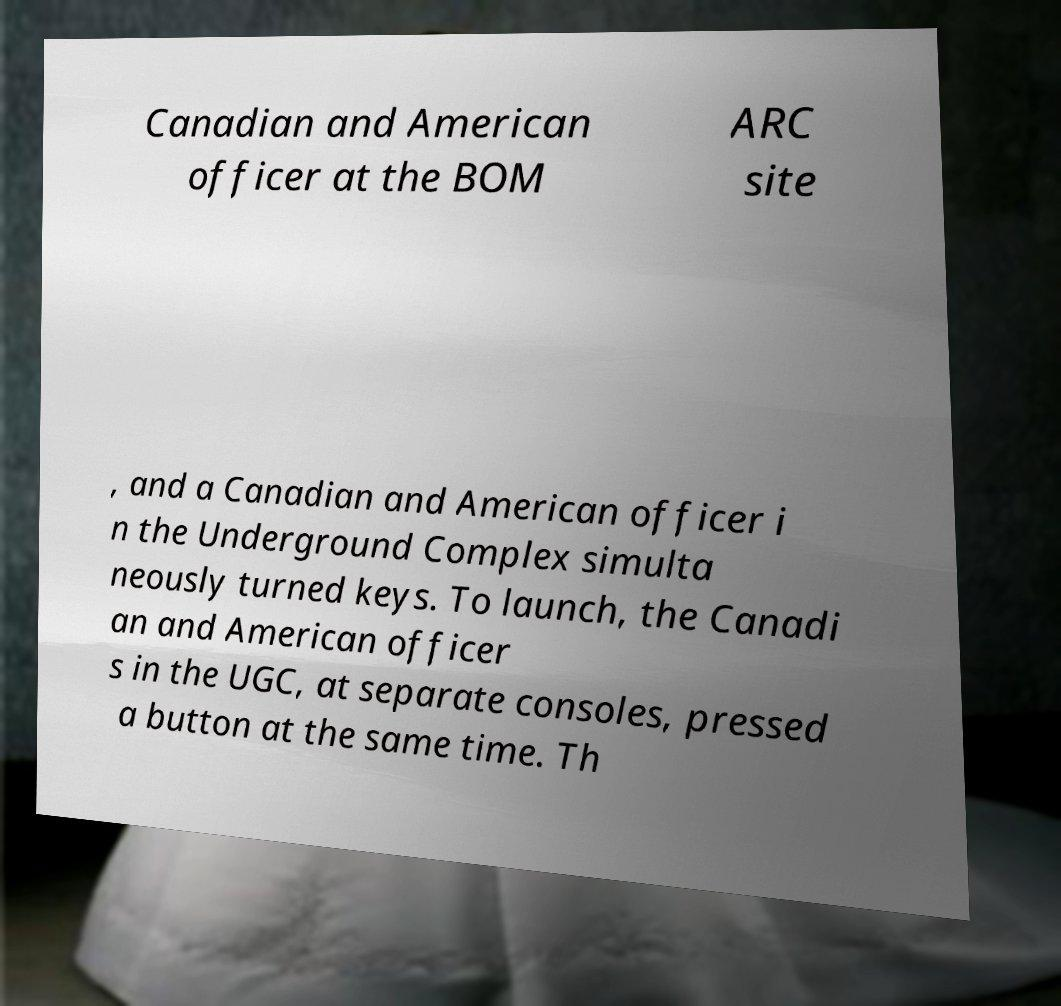Could you assist in decoding the text presented in this image and type it out clearly? Canadian and American officer at the BOM ARC site , and a Canadian and American officer i n the Underground Complex simulta neously turned keys. To launch, the Canadi an and American officer s in the UGC, at separate consoles, pressed a button at the same time. Th 